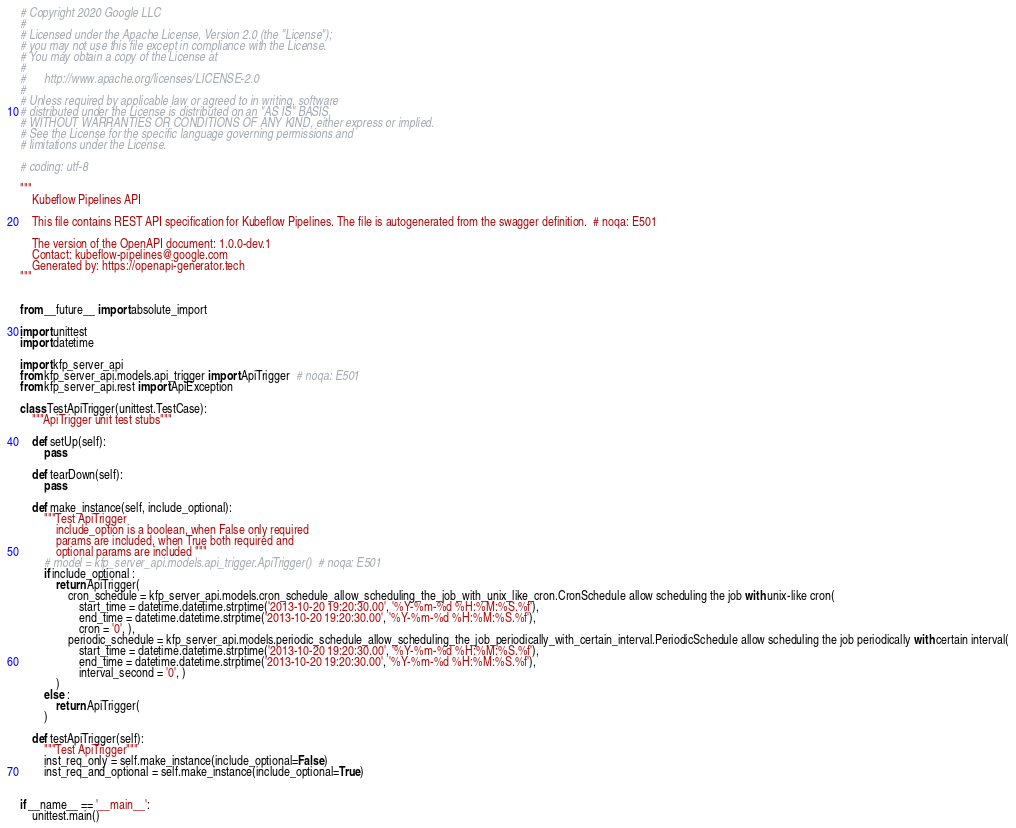Convert code to text. <code><loc_0><loc_0><loc_500><loc_500><_Python_># Copyright 2020 Google LLC
#
# Licensed under the Apache License, Version 2.0 (the "License");
# you may not use this file except in compliance with the License.
# You may obtain a copy of the License at
#
#      http://www.apache.org/licenses/LICENSE-2.0
#
# Unless required by applicable law or agreed to in writing, software
# distributed under the License is distributed on an "AS IS" BASIS,
# WITHOUT WARRANTIES OR CONDITIONS OF ANY KIND, either express or implied.
# See the License for the specific language governing permissions and
# limitations under the License.

# coding: utf-8

"""
    Kubeflow Pipelines API

    This file contains REST API specification for Kubeflow Pipelines. The file is autogenerated from the swagger definition.  # noqa: E501

    The version of the OpenAPI document: 1.0.0-dev.1
    Contact: kubeflow-pipelines@google.com
    Generated by: https://openapi-generator.tech
"""


from __future__ import absolute_import

import unittest
import datetime

import kfp_server_api
from kfp_server_api.models.api_trigger import ApiTrigger  # noqa: E501
from kfp_server_api.rest import ApiException

class TestApiTrigger(unittest.TestCase):
    """ApiTrigger unit test stubs"""

    def setUp(self):
        pass

    def tearDown(self):
        pass

    def make_instance(self, include_optional):
        """Test ApiTrigger
            include_option is a boolean, when False only required
            params are included, when True both required and
            optional params are included """
        # model = kfp_server_api.models.api_trigger.ApiTrigger()  # noqa: E501
        if include_optional :
            return ApiTrigger(
                cron_schedule = kfp_server_api.models.cron_schedule_allow_scheduling_the_job_with_unix_like_cron.CronSchedule allow scheduling the job with unix-like cron(
                    start_time = datetime.datetime.strptime('2013-10-20 19:20:30.00', '%Y-%m-%d %H:%M:%S.%f'), 
                    end_time = datetime.datetime.strptime('2013-10-20 19:20:30.00', '%Y-%m-%d %H:%M:%S.%f'), 
                    cron = '0', ), 
                periodic_schedule = kfp_server_api.models.periodic_schedule_allow_scheduling_the_job_periodically_with_certain_interval.PeriodicSchedule allow scheduling the job periodically with certain interval(
                    start_time = datetime.datetime.strptime('2013-10-20 19:20:30.00', '%Y-%m-%d %H:%M:%S.%f'), 
                    end_time = datetime.datetime.strptime('2013-10-20 19:20:30.00', '%Y-%m-%d %H:%M:%S.%f'), 
                    interval_second = '0', )
            )
        else :
            return ApiTrigger(
        )

    def testApiTrigger(self):
        """Test ApiTrigger"""
        inst_req_only = self.make_instance(include_optional=False)
        inst_req_and_optional = self.make_instance(include_optional=True)


if __name__ == '__main__':
    unittest.main()
</code> 